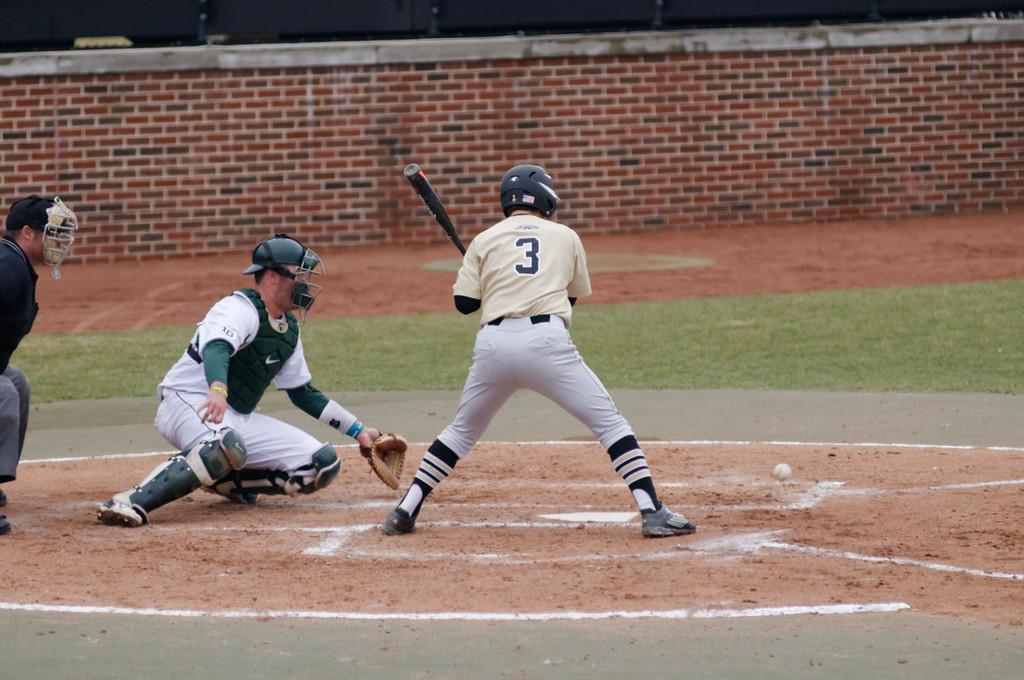<image>
Summarize the visual content of the image. A person wearing a jersey with the number 3 is playing baseball. 